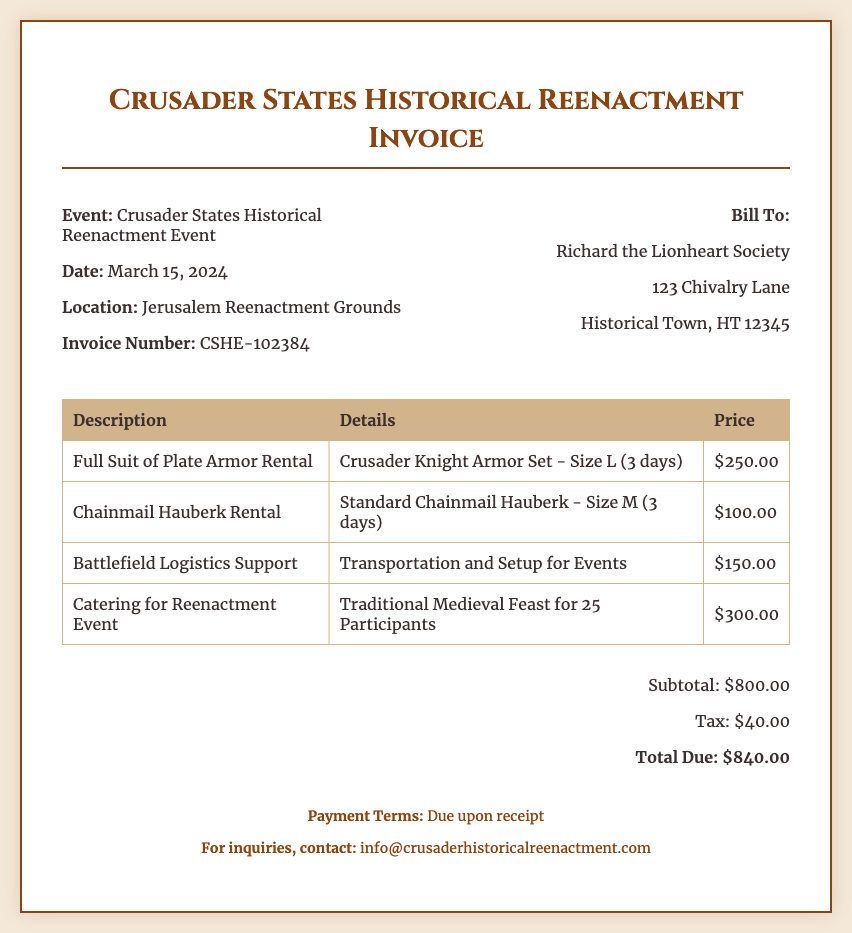What is the event name? The event name is stated in the header of the invoice under the event section.
Answer: Crusader States Historical Reenactment Event What is the invoice date? The invoice date is mentioned in the header section of the document.
Answer: March 15, 2024 Who is the bill recipient? The bill recipient is listed in the header on the right side of the document.
Answer: Richard the Lionheart Society What is the total due amount? The total due amount can be found in the total section at the bottom of the invoice.
Answer: $840.00 What is the price for the Full Suit of Plate Armor Rental? The price is indicated in the table under the relevant line item for armor rental.
Answer: $250.00 What type of catering service is included in the invoice? The type of catering service is detailed in the line item for catering in the table.
Answer: Traditional Medieval Feast for 25 Participants What is the subtotal amount before tax? The subtotal amount is listed in the total section of the document before the tax is added.
Answer: $800.00 How many days is the armor rental for? The rental duration is specified in parentheses within the line items for armor.
Answer: 3 days What is the tax amount applied? The tax amount is clearly stated in the total section.
Answer: $40.00 